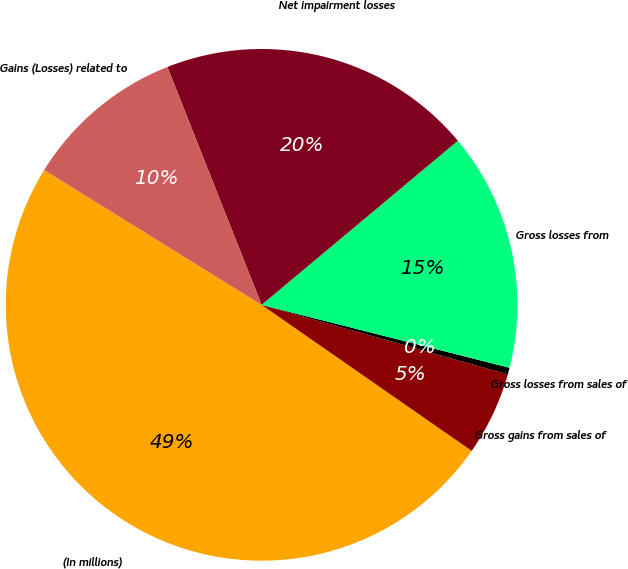Convert chart. <chart><loc_0><loc_0><loc_500><loc_500><pie_chart><fcel>(In millions)<fcel>Gross gains from sales of<fcel>Gross losses from sales of<fcel>Gross losses from<fcel>Net impairment losses<fcel>Gains (Losses) related to<nl><fcel>49.17%<fcel>5.29%<fcel>0.42%<fcel>15.04%<fcel>19.92%<fcel>10.17%<nl></chart> 